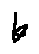Convert formula to latex. <formula><loc_0><loc_0><loc_500><loc_500>k</formula> 